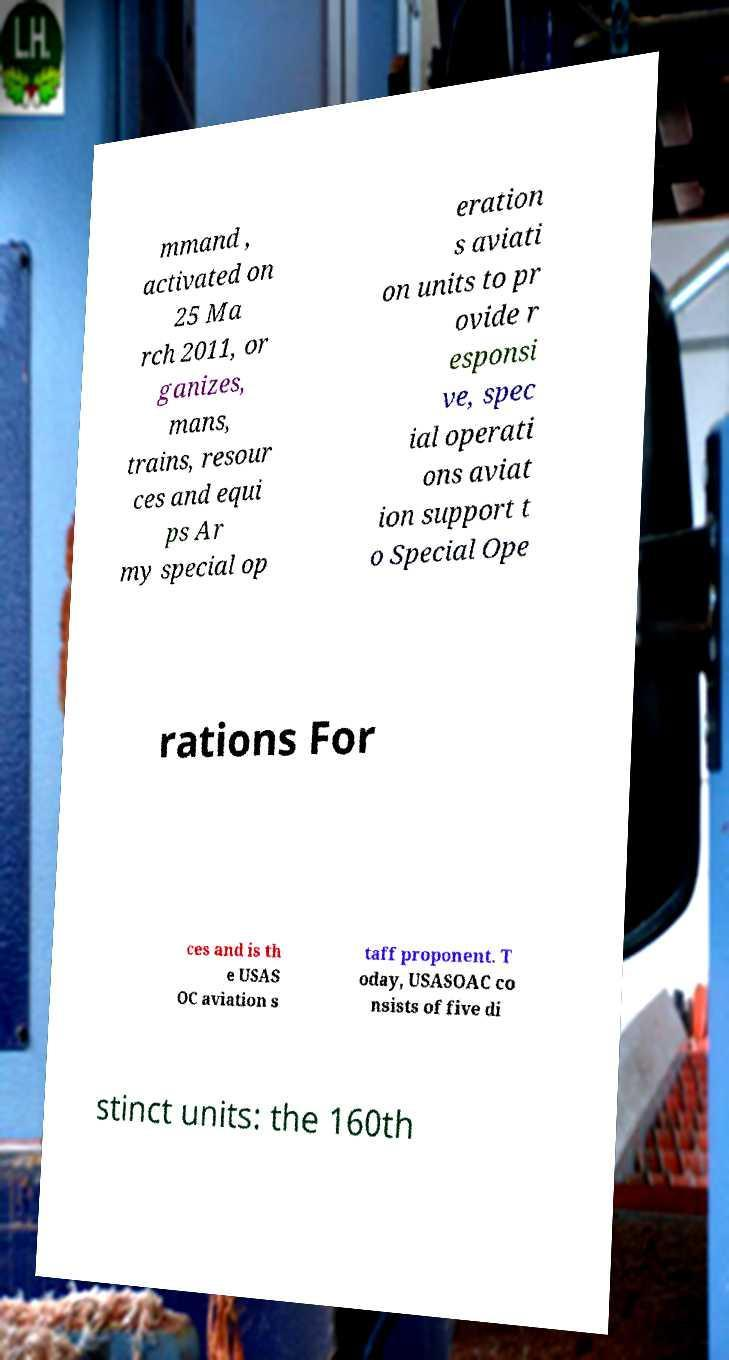I need the written content from this picture converted into text. Can you do that? mmand , activated on 25 Ma rch 2011, or ganizes, mans, trains, resour ces and equi ps Ar my special op eration s aviati on units to pr ovide r esponsi ve, spec ial operati ons aviat ion support t o Special Ope rations For ces and is th e USAS OC aviation s taff proponent. T oday, USASOAC co nsists of five di stinct units: the 160th 